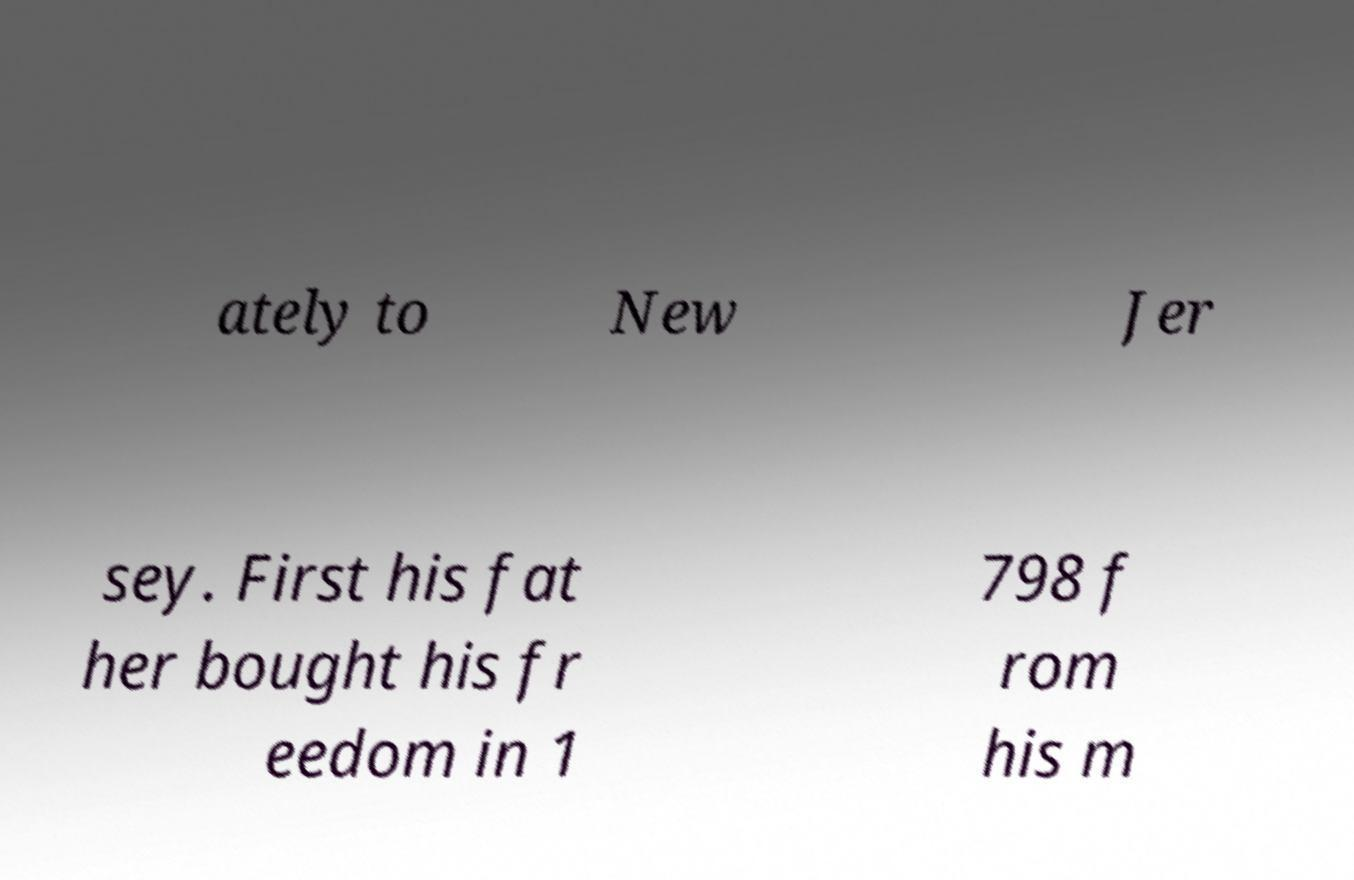For documentation purposes, I need the text within this image transcribed. Could you provide that? ately to New Jer sey. First his fat her bought his fr eedom in 1 798 f rom his m 